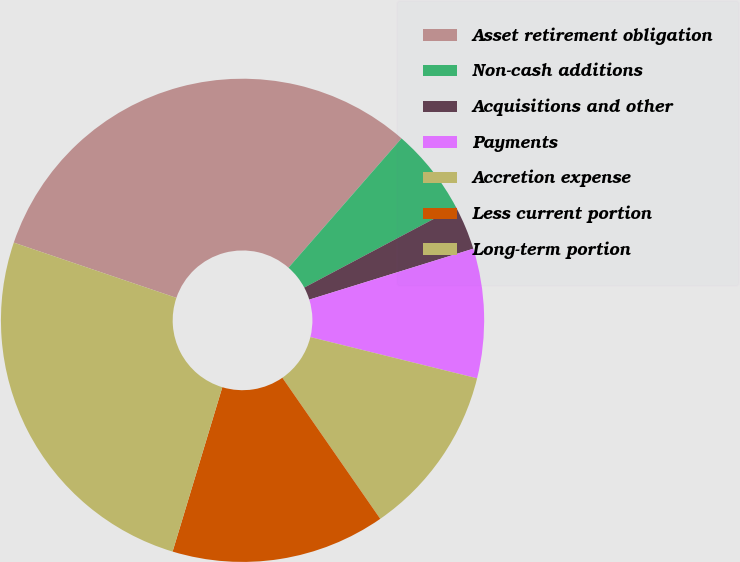Convert chart. <chart><loc_0><loc_0><loc_500><loc_500><pie_chart><fcel>Asset retirement obligation<fcel>Non-cash additions<fcel>Acquisitions and other<fcel>Payments<fcel>Accretion expense<fcel>Less current portion<fcel>Long-term portion<nl><fcel>31.22%<fcel>5.81%<fcel>2.97%<fcel>8.65%<fcel>11.49%<fcel>14.33%<fcel>25.54%<nl></chart> 